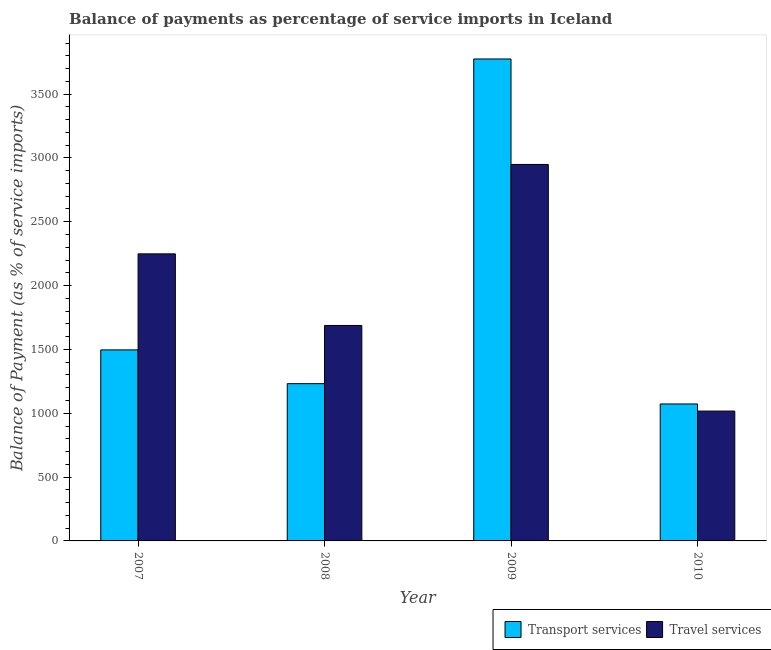How many different coloured bars are there?
Offer a very short reply. 2. How many groups of bars are there?
Keep it short and to the point. 4. Are the number of bars on each tick of the X-axis equal?
Your response must be concise. Yes. How many bars are there on the 2nd tick from the left?
Ensure brevity in your answer.  2. What is the label of the 4th group of bars from the left?
Ensure brevity in your answer.  2010. In how many cases, is the number of bars for a given year not equal to the number of legend labels?
Provide a short and direct response. 0. What is the balance of payments of transport services in 2010?
Offer a very short reply. 1072.78. Across all years, what is the maximum balance of payments of travel services?
Your response must be concise. 2948.8. Across all years, what is the minimum balance of payments of travel services?
Your answer should be very brief. 1017.05. In which year was the balance of payments of travel services maximum?
Provide a short and direct response. 2009. In which year was the balance of payments of travel services minimum?
Make the answer very short. 2010. What is the total balance of payments of transport services in the graph?
Keep it short and to the point. 7575.73. What is the difference between the balance of payments of travel services in 2007 and that in 2009?
Keep it short and to the point. -700.37. What is the difference between the balance of payments of transport services in 2008 and the balance of payments of travel services in 2007?
Ensure brevity in your answer.  -264.42. What is the average balance of payments of transport services per year?
Give a very brief answer. 1893.93. In the year 2007, what is the difference between the balance of payments of travel services and balance of payments of transport services?
Provide a succinct answer. 0. In how many years, is the balance of payments of transport services greater than 2700 %?
Your answer should be compact. 1. What is the ratio of the balance of payments of travel services in 2008 to that in 2010?
Ensure brevity in your answer.  1.66. Is the balance of payments of travel services in 2009 less than that in 2010?
Your response must be concise. No. What is the difference between the highest and the second highest balance of payments of transport services?
Make the answer very short. 2278.71. What is the difference between the highest and the lowest balance of payments of transport services?
Your answer should be very brief. 2702.14. In how many years, is the balance of payments of transport services greater than the average balance of payments of transport services taken over all years?
Your response must be concise. 1. Is the sum of the balance of payments of transport services in 2007 and 2008 greater than the maximum balance of payments of travel services across all years?
Offer a terse response. No. What does the 1st bar from the left in 2008 represents?
Give a very brief answer. Transport services. What does the 1st bar from the right in 2008 represents?
Keep it short and to the point. Travel services. How many bars are there?
Provide a short and direct response. 8. Are all the bars in the graph horizontal?
Provide a succinct answer. No. What is the difference between two consecutive major ticks on the Y-axis?
Offer a very short reply. 500. Where does the legend appear in the graph?
Give a very brief answer. Bottom right. What is the title of the graph?
Provide a short and direct response. Balance of payments as percentage of service imports in Iceland. Does "Male" appear as one of the legend labels in the graph?
Keep it short and to the point. No. What is the label or title of the Y-axis?
Offer a very short reply. Balance of Payment (as % of service imports). What is the Balance of Payment (as % of service imports) of Transport services in 2007?
Provide a short and direct response. 1496.22. What is the Balance of Payment (as % of service imports) of Travel services in 2007?
Your answer should be very brief. 2248.42. What is the Balance of Payment (as % of service imports) of Transport services in 2008?
Give a very brief answer. 1231.8. What is the Balance of Payment (as % of service imports) of Travel services in 2008?
Your answer should be compact. 1687.56. What is the Balance of Payment (as % of service imports) in Transport services in 2009?
Your answer should be compact. 3774.93. What is the Balance of Payment (as % of service imports) of Travel services in 2009?
Give a very brief answer. 2948.8. What is the Balance of Payment (as % of service imports) in Transport services in 2010?
Ensure brevity in your answer.  1072.78. What is the Balance of Payment (as % of service imports) of Travel services in 2010?
Provide a short and direct response. 1017.05. Across all years, what is the maximum Balance of Payment (as % of service imports) in Transport services?
Offer a terse response. 3774.93. Across all years, what is the maximum Balance of Payment (as % of service imports) in Travel services?
Your response must be concise. 2948.8. Across all years, what is the minimum Balance of Payment (as % of service imports) in Transport services?
Provide a short and direct response. 1072.78. Across all years, what is the minimum Balance of Payment (as % of service imports) of Travel services?
Provide a succinct answer. 1017.05. What is the total Balance of Payment (as % of service imports) in Transport services in the graph?
Your answer should be very brief. 7575.73. What is the total Balance of Payment (as % of service imports) in Travel services in the graph?
Your answer should be very brief. 7901.83. What is the difference between the Balance of Payment (as % of service imports) in Transport services in 2007 and that in 2008?
Your answer should be compact. 264.42. What is the difference between the Balance of Payment (as % of service imports) in Travel services in 2007 and that in 2008?
Your answer should be compact. 560.86. What is the difference between the Balance of Payment (as % of service imports) in Transport services in 2007 and that in 2009?
Offer a terse response. -2278.71. What is the difference between the Balance of Payment (as % of service imports) of Travel services in 2007 and that in 2009?
Offer a terse response. -700.37. What is the difference between the Balance of Payment (as % of service imports) of Transport services in 2007 and that in 2010?
Your response must be concise. 423.44. What is the difference between the Balance of Payment (as % of service imports) of Travel services in 2007 and that in 2010?
Your response must be concise. 1231.38. What is the difference between the Balance of Payment (as % of service imports) in Transport services in 2008 and that in 2009?
Give a very brief answer. -2543.13. What is the difference between the Balance of Payment (as % of service imports) of Travel services in 2008 and that in 2009?
Give a very brief answer. -1261.23. What is the difference between the Balance of Payment (as % of service imports) in Transport services in 2008 and that in 2010?
Keep it short and to the point. 159.01. What is the difference between the Balance of Payment (as % of service imports) of Travel services in 2008 and that in 2010?
Offer a terse response. 670.52. What is the difference between the Balance of Payment (as % of service imports) in Transport services in 2009 and that in 2010?
Your answer should be compact. 2702.14. What is the difference between the Balance of Payment (as % of service imports) in Travel services in 2009 and that in 2010?
Keep it short and to the point. 1931.75. What is the difference between the Balance of Payment (as % of service imports) of Transport services in 2007 and the Balance of Payment (as % of service imports) of Travel services in 2008?
Your response must be concise. -191.34. What is the difference between the Balance of Payment (as % of service imports) in Transport services in 2007 and the Balance of Payment (as % of service imports) in Travel services in 2009?
Make the answer very short. -1452.57. What is the difference between the Balance of Payment (as % of service imports) of Transport services in 2007 and the Balance of Payment (as % of service imports) of Travel services in 2010?
Offer a very short reply. 479.18. What is the difference between the Balance of Payment (as % of service imports) of Transport services in 2008 and the Balance of Payment (as % of service imports) of Travel services in 2009?
Keep it short and to the point. -1717. What is the difference between the Balance of Payment (as % of service imports) of Transport services in 2008 and the Balance of Payment (as % of service imports) of Travel services in 2010?
Provide a succinct answer. 214.75. What is the difference between the Balance of Payment (as % of service imports) in Transport services in 2009 and the Balance of Payment (as % of service imports) in Travel services in 2010?
Provide a succinct answer. 2757.88. What is the average Balance of Payment (as % of service imports) in Transport services per year?
Your response must be concise. 1893.93. What is the average Balance of Payment (as % of service imports) in Travel services per year?
Make the answer very short. 1975.46. In the year 2007, what is the difference between the Balance of Payment (as % of service imports) in Transport services and Balance of Payment (as % of service imports) in Travel services?
Offer a very short reply. -752.2. In the year 2008, what is the difference between the Balance of Payment (as % of service imports) in Transport services and Balance of Payment (as % of service imports) in Travel services?
Provide a succinct answer. -455.76. In the year 2009, what is the difference between the Balance of Payment (as % of service imports) of Transport services and Balance of Payment (as % of service imports) of Travel services?
Make the answer very short. 826.13. In the year 2010, what is the difference between the Balance of Payment (as % of service imports) of Transport services and Balance of Payment (as % of service imports) of Travel services?
Keep it short and to the point. 55.74. What is the ratio of the Balance of Payment (as % of service imports) of Transport services in 2007 to that in 2008?
Ensure brevity in your answer.  1.21. What is the ratio of the Balance of Payment (as % of service imports) of Travel services in 2007 to that in 2008?
Provide a succinct answer. 1.33. What is the ratio of the Balance of Payment (as % of service imports) of Transport services in 2007 to that in 2009?
Ensure brevity in your answer.  0.4. What is the ratio of the Balance of Payment (as % of service imports) of Travel services in 2007 to that in 2009?
Keep it short and to the point. 0.76. What is the ratio of the Balance of Payment (as % of service imports) in Transport services in 2007 to that in 2010?
Provide a succinct answer. 1.39. What is the ratio of the Balance of Payment (as % of service imports) of Travel services in 2007 to that in 2010?
Give a very brief answer. 2.21. What is the ratio of the Balance of Payment (as % of service imports) in Transport services in 2008 to that in 2009?
Your response must be concise. 0.33. What is the ratio of the Balance of Payment (as % of service imports) of Travel services in 2008 to that in 2009?
Offer a terse response. 0.57. What is the ratio of the Balance of Payment (as % of service imports) of Transport services in 2008 to that in 2010?
Provide a short and direct response. 1.15. What is the ratio of the Balance of Payment (as % of service imports) of Travel services in 2008 to that in 2010?
Keep it short and to the point. 1.66. What is the ratio of the Balance of Payment (as % of service imports) of Transport services in 2009 to that in 2010?
Offer a very short reply. 3.52. What is the ratio of the Balance of Payment (as % of service imports) in Travel services in 2009 to that in 2010?
Your response must be concise. 2.9. What is the difference between the highest and the second highest Balance of Payment (as % of service imports) in Transport services?
Offer a terse response. 2278.71. What is the difference between the highest and the second highest Balance of Payment (as % of service imports) of Travel services?
Make the answer very short. 700.37. What is the difference between the highest and the lowest Balance of Payment (as % of service imports) of Transport services?
Your response must be concise. 2702.14. What is the difference between the highest and the lowest Balance of Payment (as % of service imports) of Travel services?
Keep it short and to the point. 1931.75. 